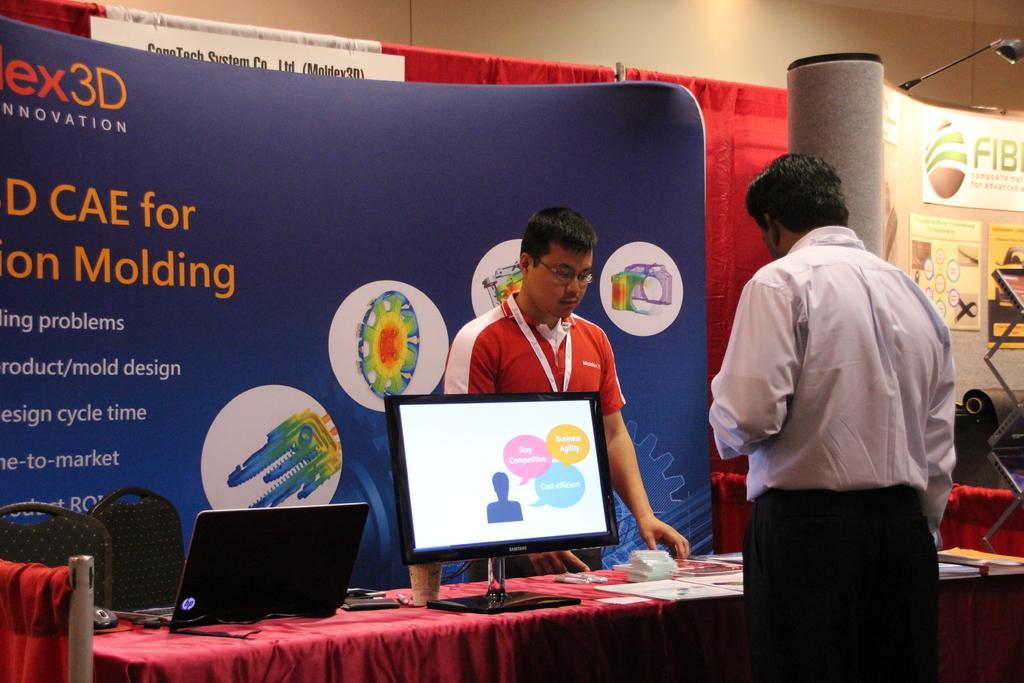How would you summarize this image in a sentence or two? In this image we can see two men standing beside a table containing some laptops, wires, a mouse and some papers on it. We can also see some chairs, pillar, a light with a stand, a metal frame, a board with some text on it, some curtains with the poles and a wall. 